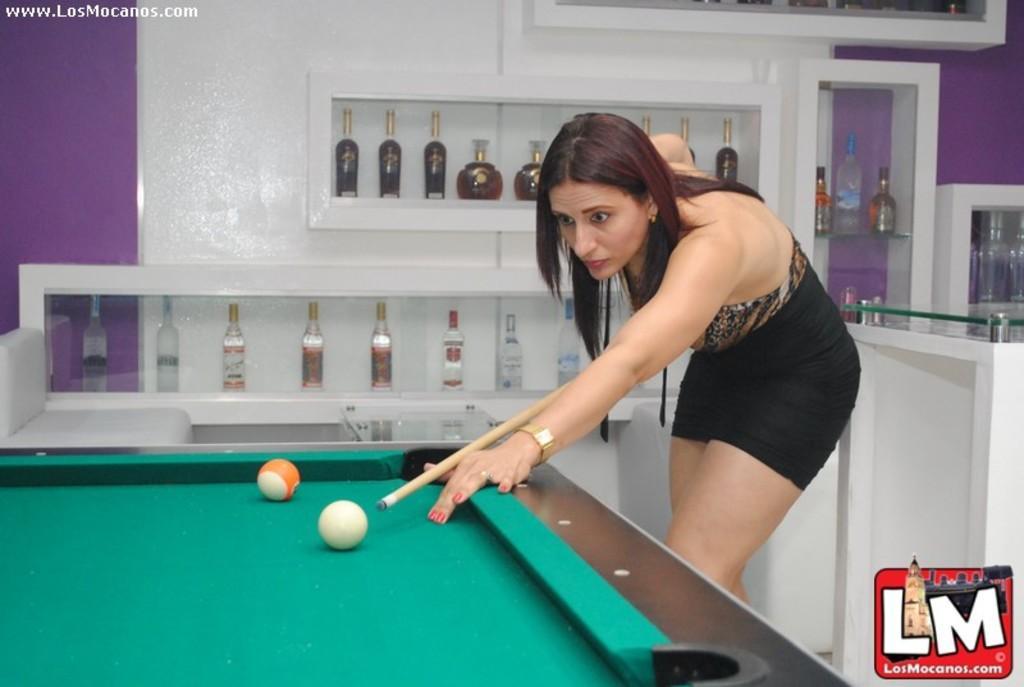Please provide a concise description of this image. In this image we can see a woman wearing a dress is holding a stick with her hands is standing beside a table. In the foreground we can see balls placed on the table. In the background, we can see group of bottles placed on racks, table. At the bottom we can see a logo and some text. 